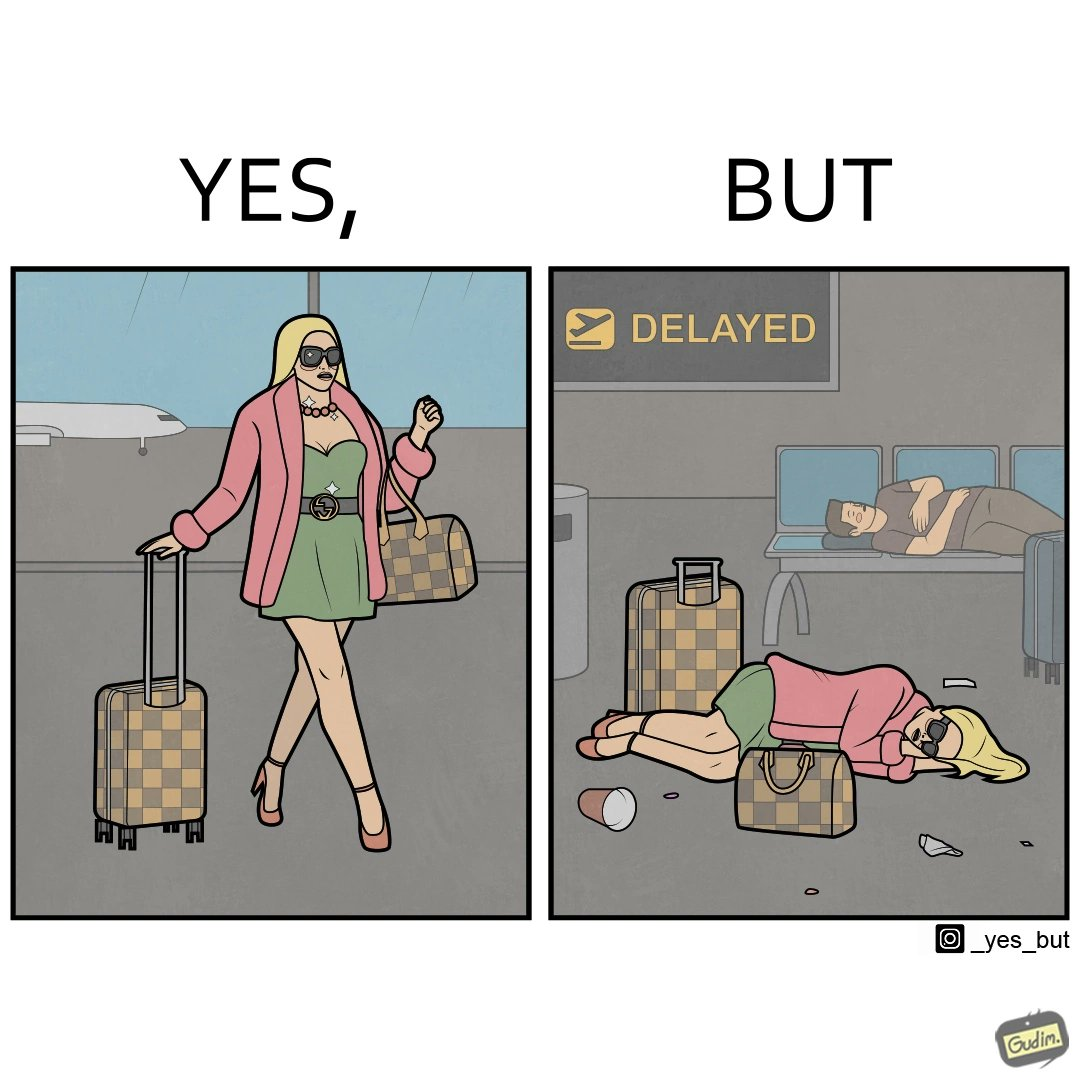What is shown in this image? The image is ironical, as an apparently rich person walks inside the airport with luggage, but has to sleep on the floor  due to the flight being delayed and an absence of vacant seats in the airport. 